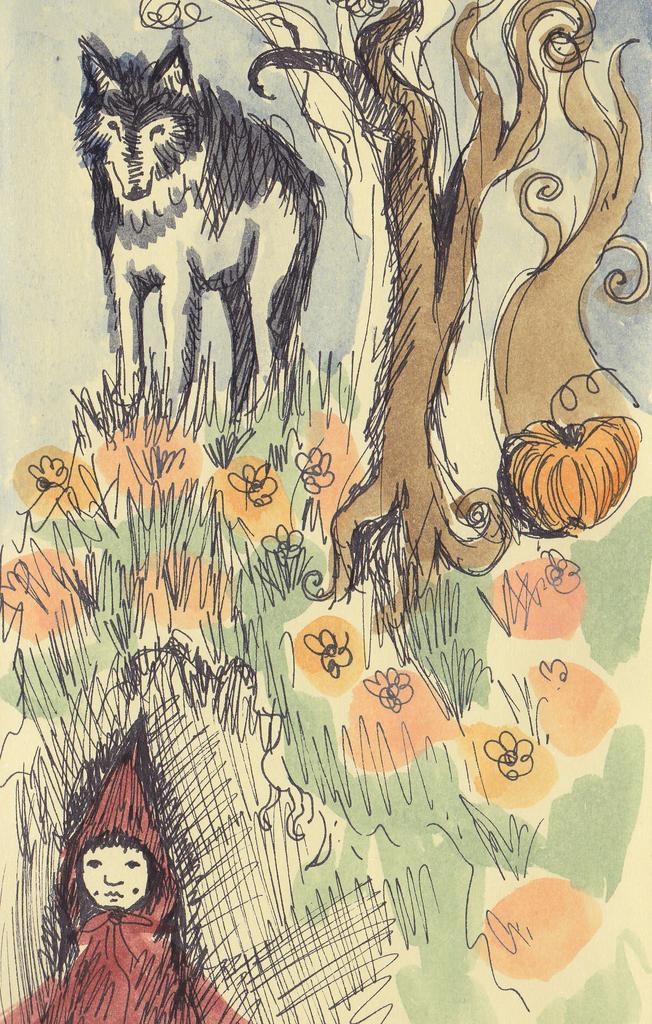What is the main subject of the image? The image contains a sketch. What types of objects or elements are included in the sketch? The sketch includes an animal, trees, pumpkins, and grass. Is there any human presence in the sketch? Yes, there is a person at the bottom of the sketch. What type of canvas is the person using to create the sketch in the image? The image does not provide information about the canvas or medium used for the sketch. What kind of dinner is the person having with the fairies in the image? There are no fairies or dinner depicted in the image; it only shows a sketch with various elements. 